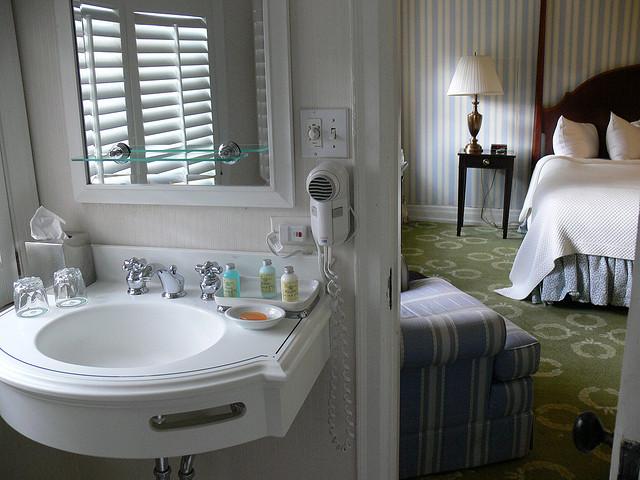What room is the picture taken from?
Give a very brief answer. Bathroom. Is this a room in a private home?
Give a very brief answer. Yes. What is on the wall under the light switch?
Quick response, please. Hair dryer. 